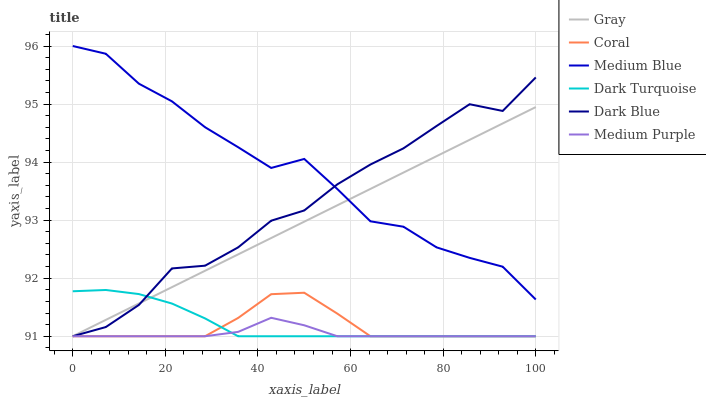Does Medium Purple have the minimum area under the curve?
Answer yes or no. Yes. Does Medium Blue have the maximum area under the curve?
Answer yes or no. Yes. Does Dark Turquoise have the minimum area under the curve?
Answer yes or no. No. Does Dark Turquoise have the maximum area under the curve?
Answer yes or no. No. Is Gray the smoothest?
Answer yes or no. Yes. Is Dark Blue the roughest?
Answer yes or no. Yes. Is Dark Turquoise the smoothest?
Answer yes or no. No. Is Dark Turquoise the roughest?
Answer yes or no. No. Does Medium Blue have the lowest value?
Answer yes or no. No. Does Medium Blue have the highest value?
Answer yes or no. Yes. Does Dark Turquoise have the highest value?
Answer yes or no. No. Is Medium Purple less than Medium Blue?
Answer yes or no. Yes. Is Medium Blue greater than Medium Purple?
Answer yes or no. Yes. Does Gray intersect Medium Purple?
Answer yes or no. Yes. Is Gray less than Medium Purple?
Answer yes or no. No. Is Gray greater than Medium Purple?
Answer yes or no. No. Does Medium Purple intersect Medium Blue?
Answer yes or no. No. 